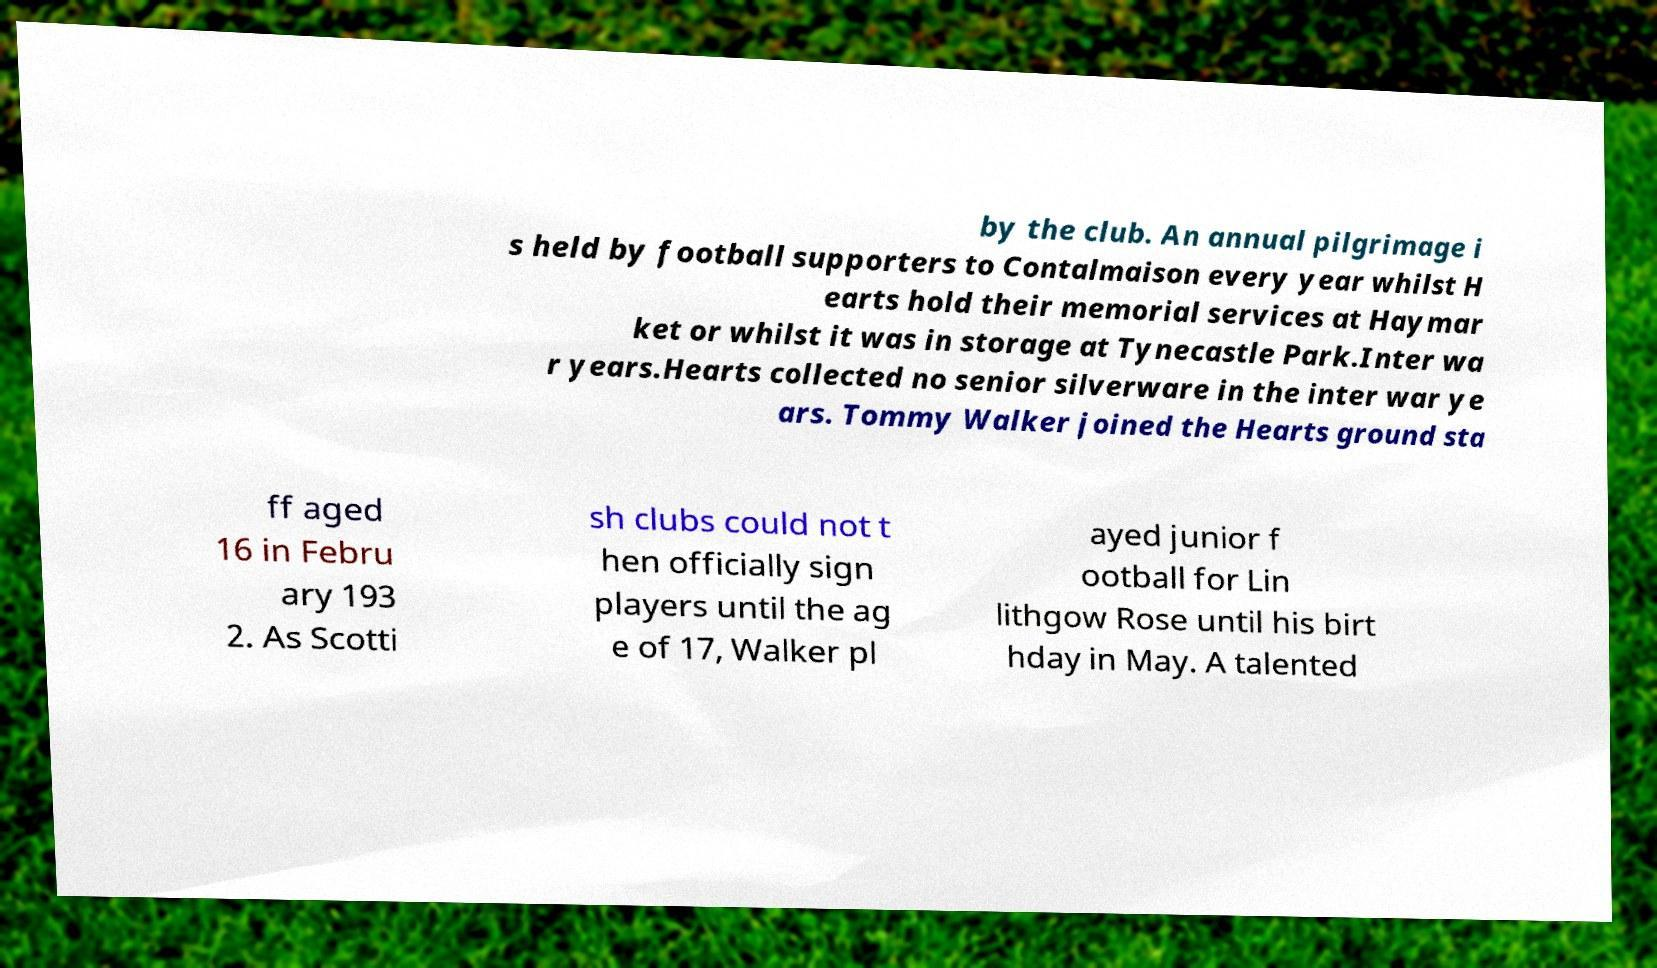There's text embedded in this image that I need extracted. Can you transcribe it verbatim? by the club. An annual pilgrimage i s held by football supporters to Contalmaison every year whilst H earts hold their memorial services at Haymar ket or whilst it was in storage at Tynecastle Park.Inter wa r years.Hearts collected no senior silverware in the inter war ye ars. Tommy Walker joined the Hearts ground sta ff aged 16 in Febru ary 193 2. As Scotti sh clubs could not t hen officially sign players until the ag e of 17, Walker pl ayed junior f ootball for Lin lithgow Rose until his birt hday in May. A talented 